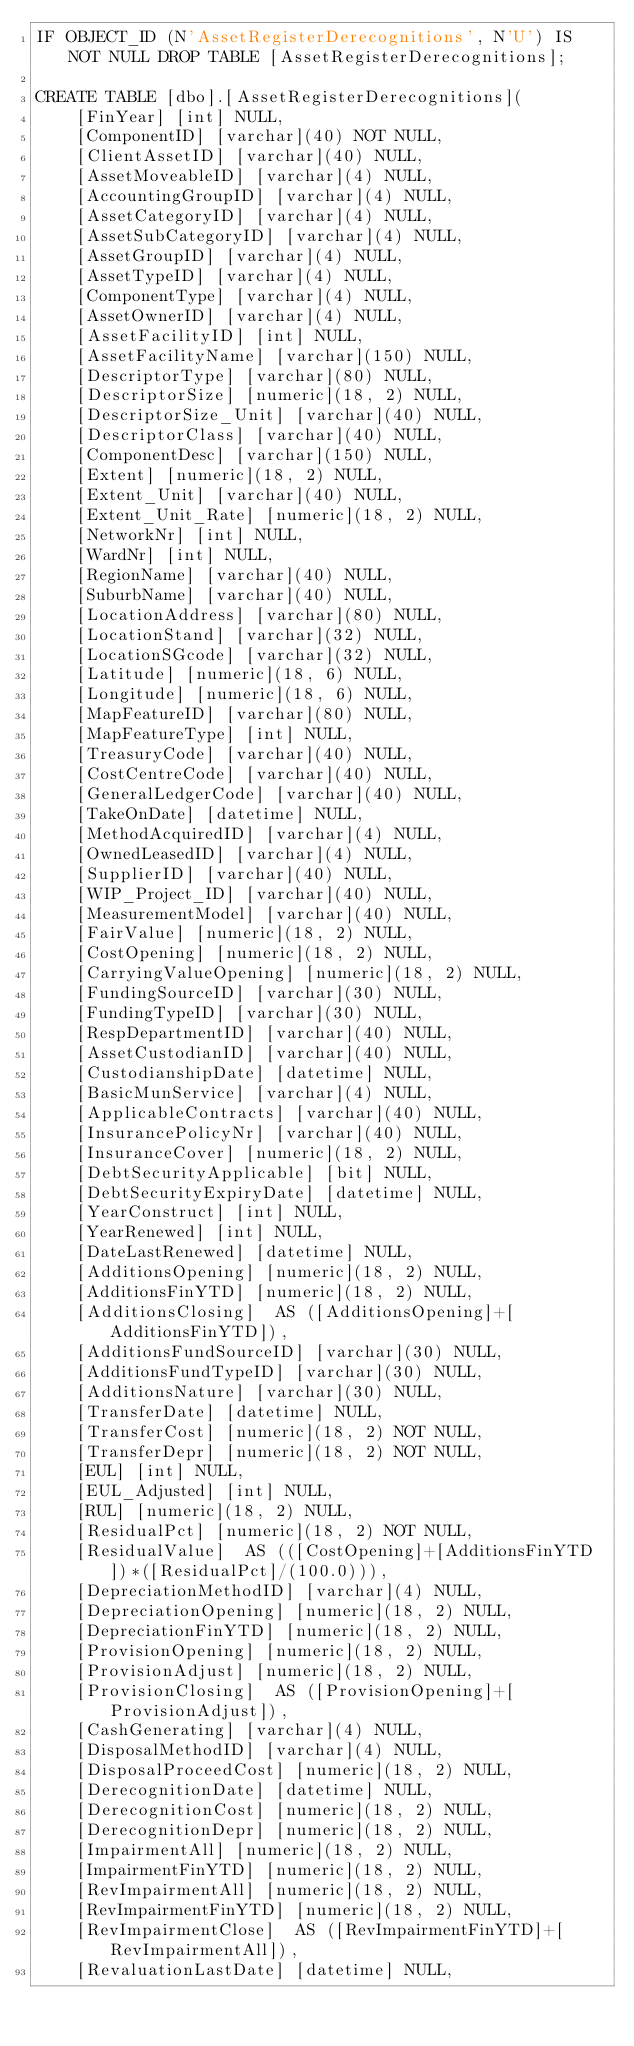<code> <loc_0><loc_0><loc_500><loc_500><_SQL_>IF OBJECT_ID (N'AssetRegisterDerecognitions', N'U') IS NOT NULL DROP TABLE [AssetRegisterDerecognitions];

CREATE TABLE [dbo].[AssetRegisterDerecognitions](
	[FinYear] [int] NULL,
	[ComponentID] [varchar](40) NOT NULL,
	[ClientAssetID] [varchar](40) NULL,
	[AssetMoveableID] [varchar](4) NULL,
	[AccountingGroupID] [varchar](4) NULL,
	[AssetCategoryID] [varchar](4) NULL,
	[AssetSubCategoryID] [varchar](4) NULL,
	[AssetGroupID] [varchar](4) NULL,
	[AssetTypeID] [varchar](4) NULL,
	[ComponentType] [varchar](4) NULL,
	[AssetOwnerID] [varchar](4) NULL,
	[AssetFacilityID] [int] NULL,
	[AssetFacilityName] [varchar](150) NULL,
	[DescriptorType] [varchar](80) NULL,
	[DescriptorSize] [numeric](18, 2) NULL,
	[DescriptorSize_Unit] [varchar](40) NULL,
	[DescriptorClass] [varchar](40) NULL,
	[ComponentDesc] [varchar](150) NULL,
	[Extent] [numeric](18, 2) NULL,
	[Extent_Unit] [varchar](40) NULL,
	[Extent_Unit_Rate] [numeric](18, 2) NULL,
	[NetworkNr] [int] NULL,
	[WardNr] [int] NULL,
	[RegionName] [varchar](40) NULL,
	[SuburbName] [varchar](40) NULL,
	[LocationAddress] [varchar](80) NULL,
	[LocationStand] [varchar](32) NULL,
	[LocationSGcode] [varchar](32) NULL,
	[Latitude] [numeric](18, 6) NULL,
	[Longitude] [numeric](18, 6) NULL,
	[MapFeatureID] [varchar](80) NULL,
	[MapFeatureType] [int] NULL,
	[TreasuryCode] [varchar](40) NULL,
	[CostCentreCode] [varchar](40) NULL,
	[GeneralLedgerCode] [varchar](40) NULL,
	[TakeOnDate] [datetime] NULL,
	[MethodAcquiredID] [varchar](4) NULL,
	[OwnedLeasedID] [varchar](4) NULL,
	[SupplierID] [varchar](40) NULL,
	[WIP_Project_ID] [varchar](40) NULL,
	[MeasurementModel] [varchar](40) NULL,
	[FairValue] [numeric](18, 2) NULL,
	[CostOpening] [numeric](18, 2) NULL,
	[CarryingValueOpening] [numeric](18, 2) NULL,
	[FundingSourceID] [varchar](30) NULL,
	[FundingTypeID] [varchar](30) NULL,
	[RespDepartmentID] [varchar](40) NULL,
	[AssetCustodianID] [varchar](40) NULL,
	[CustodianshipDate] [datetime] NULL,
	[BasicMunService] [varchar](4) NULL,
	[ApplicableContracts] [varchar](40) NULL,
	[InsurancePolicyNr] [varchar](40) NULL,
	[InsuranceCover] [numeric](18, 2) NULL,
	[DebtSecurityApplicable] [bit] NULL,
	[DebtSecurityExpiryDate] [datetime] NULL,
	[YearConstruct] [int] NULL,
	[YearRenewed] [int] NULL,
	[DateLastRenewed] [datetime] NULL,
	[AdditionsOpening] [numeric](18, 2) NULL,
	[AdditionsFinYTD] [numeric](18, 2) NULL,
	[AdditionsClosing]  AS ([AdditionsOpening]+[AdditionsFinYTD]),
	[AdditionsFundSourceID] [varchar](30) NULL,
	[AdditionsFundTypeID] [varchar](30) NULL,
	[AdditionsNature] [varchar](30) NULL,
	[TransferDate] [datetime] NULL,
	[TransferCost] [numeric](18, 2) NOT NULL,
	[TransferDepr] [numeric](18, 2) NOT NULL,
	[EUL] [int] NULL,
	[EUL_Adjusted] [int] NULL,
	[RUL] [numeric](18, 2) NULL,
	[ResidualPct] [numeric](18, 2) NOT NULL,
	[ResidualValue]  AS (([CostOpening]+[AdditionsFinYTD])*([ResidualPct]/(100.0))),
	[DepreciationMethodID] [varchar](4) NULL,
	[DepreciationOpening] [numeric](18, 2) NULL,
	[DepreciationFinYTD] [numeric](18, 2) NULL,
	[ProvisionOpening] [numeric](18, 2) NULL,
	[ProvisionAdjust] [numeric](18, 2) NULL,
	[ProvisionClosing]  AS ([ProvisionOpening]+[ProvisionAdjust]),
	[CashGenerating] [varchar](4) NULL,
	[DisposalMethodID] [varchar](4) NULL,
	[DisposalProceedCost] [numeric](18, 2) NULL,
	[DerecognitionDate] [datetime] NULL,
	[DerecognitionCost] [numeric](18, 2) NULL,
	[DerecognitionDepr] [numeric](18, 2) NULL,
	[ImpairmentAll] [numeric](18, 2) NULL,
	[ImpairmentFinYTD] [numeric](18, 2) NULL,
	[RevImpairmentAll] [numeric](18, 2) NULL,
	[RevImpairmentFinYTD] [numeric](18, 2) NULL,
	[RevImpairmentClose]  AS ([RevImpairmentFinYTD]+[RevImpairmentAll]),
	[RevaluationLastDate] [datetime] NULL,</code> 